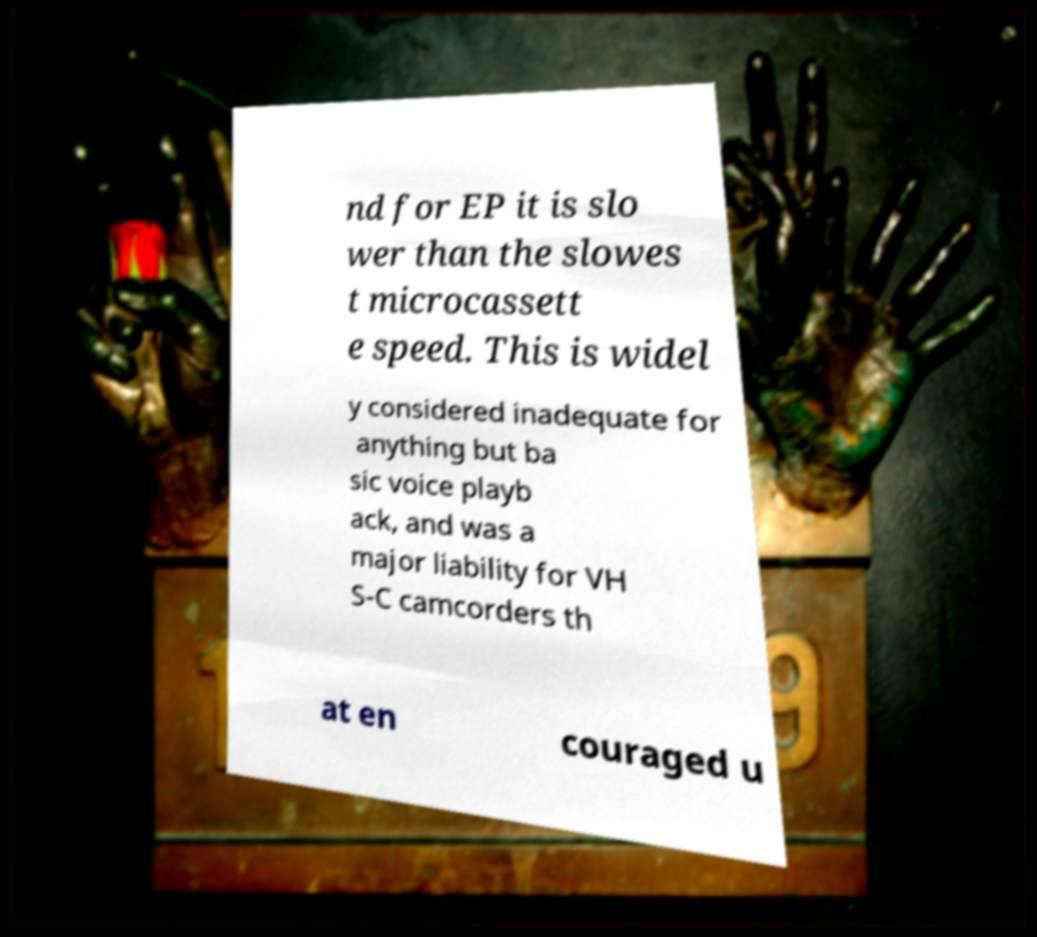What messages or text are displayed in this image? I need them in a readable, typed format. nd for EP it is slo wer than the slowes t microcassett e speed. This is widel y considered inadequate for anything but ba sic voice playb ack, and was a major liability for VH S-C camcorders th at en couraged u 